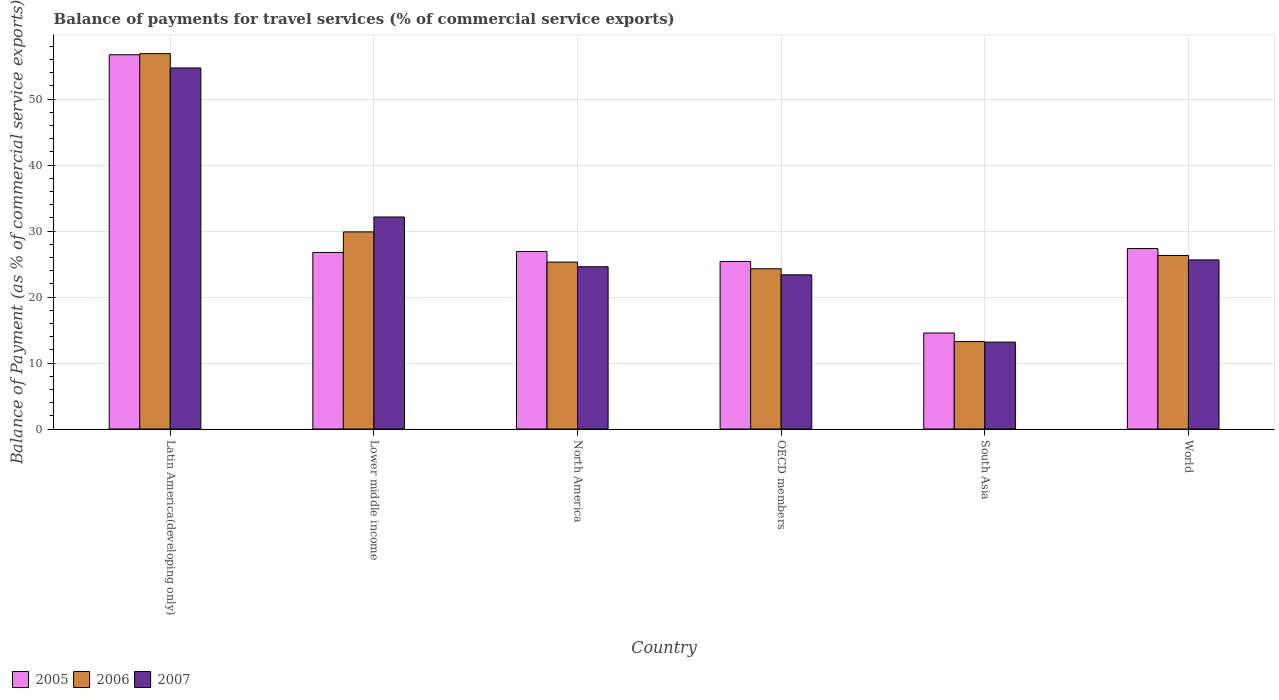How many different coloured bars are there?
Ensure brevity in your answer.  3. In how many cases, is the number of bars for a given country not equal to the number of legend labels?
Your response must be concise. 0. What is the balance of payments for travel services in 2006 in North America?
Offer a terse response. 25.3. Across all countries, what is the maximum balance of payments for travel services in 2005?
Your answer should be compact. 56.72. Across all countries, what is the minimum balance of payments for travel services in 2007?
Ensure brevity in your answer.  13.17. In which country was the balance of payments for travel services in 2006 maximum?
Give a very brief answer. Latin America(developing only). In which country was the balance of payments for travel services in 2007 minimum?
Give a very brief answer. South Asia. What is the total balance of payments for travel services in 2007 in the graph?
Provide a short and direct response. 173.6. What is the difference between the balance of payments for travel services in 2007 in OECD members and that in World?
Give a very brief answer. -2.26. What is the difference between the balance of payments for travel services in 2007 in North America and the balance of payments for travel services in 2006 in South Asia?
Your response must be concise. 11.34. What is the average balance of payments for travel services in 2007 per country?
Keep it short and to the point. 28.93. What is the difference between the balance of payments for travel services of/in 2005 and balance of payments for travel services of/in 2007 in World?
Make the answer very short. 1.72. What is the ratio of the balance of payments for travel services in 2005 in Latin America(developing only) to that in South Asia?
Make the answer very short. 3.9. Is the difference between the balance of payments for travel services in 2005 in Lower middle income and OECD members greater than the difference between the balance of payments for travel services in 2007 in Lower middle income and OECD members?
Ensure brevity in your answer.  No. What is the difference between the highest and the second highest balance of payments for travel services in 2007?
Your answer should be very brief. 6.51. What is the difference between the highest and the lowest balance of payments for travel services in 2005?
Your answer should be compact. 42.17. What does the 1st bar from the left in South Asia represents?
Ensure brevity in your answer.  2005. What does the 1st bar from the right in North America represents?
Provide a succinct answer. 2007. Is it the case that in every country, the sum of the balance of payments for travel services in 2005 and balance of payments for travel services in 2007 is greater than the balance of payments for travel services in 2006?
Give a very brief answer. Yes. How many bars are there?
Make the answer very short. 18. Are all the bars in the graph horizontal?
Make the answer very short. No. What is the difference between two consecutive major ticks on the Y-axis?
Your response must be concise. 10. Does the graph contain any zero values?
Offer a very short reply. No. Does the graph contain grids?
Make the answer very short. Yes. What is the title of the graph?
Your answer should be very brief. Balance of payments for travel services (% of commercial service exports). What is the label or title of the X-axis?
Your answer should be very brief. Country. What is the label or title of the Y-axis?
Keep it short and to the point. Balance of Payment (as % of commercial service exports). What is the Balance of Payment (as % of commercial service exports) of 2005 in Latin America(developing only)?
Your response must be concise. 56.72. What is the Balance of Payment (as % of commercial service exports) of 2006 in Latin America(developing only)?
Ensure brevity in your answer.  56.89. What is the Balance of Payment (as % of commercial service exports) of 2007 in Latin America(developing only)?
Provide a succinct answer. 54.72. What is the Balance of Payment (as % of commercial service exports) in 2005 in Lower middle income?
Your response must be concise. 26.76. What is the Balance of Payment (as % of commercial service exports) of 2006 in Lower middle income?
Make the answer very short. 29.87. What is the Balance of Payment (as % of commercial service exports) of 2007 in Lower middle income?
Your answer should be compact. 32.13. What is the Balance of Payment (as % of commercial service exports) of 2005 in North America?
Give a very brief answer. 26.9. What is the Balance of Payment (as % of commercial service exports) of 2006 in North America?
Offer a very short reply. 25.3. What is the Balance of Payment (as % of commercial service exports) of 2007 in North America?
Provide a succinct answer. 24.59. What is the Balance of Payment (as % of commercial service exports) in 2005 in OECD members?
Your response must be concise. 25.39. What is the Balance of Payment (as % of commercial service exports) of 2006 in OECD members?
Provide a short and direct response. 24.29. What is the Balance of Payment (as % of commercial service exports) of 2007 in OECD members?
Give a very brief answer. 23.36. What is the Balance of Payment (as % of commercial service exports) of 2005 in South Asia?
Offer a very short reply. 14.55. What is the Balance of Payment (as % of commercial service exports) of 2006 in South Asia?
Your answer should be very brief. 13.25. What is the Balance of Payment (as % of commercial service exports) of 2007 in South Asia?
Offer a very short reply. 13.17. What is the Balance of Payment (as % of commercial service exports) in 2005 in World?
Give a very brief answer. 27.35. What is the Balance of Payment (as % of commercial service exports) of 2006 in World?
Offer a terse response. 26.3. What is the Balance of Payment (as % of commercial service exports) in 2007 in World?
Offer a very short reply. 25.63. Across all countries, what is the maximum Balance of Payment (as % of commercial service exports) in 2005?
Provide a succinct answer. 56.72. Across all countries, what is the maximum Balance of Payment (as % of commercial service exports) of 2006?
Make the answer very short. 56.89. Across all countries, what is the maximum Balance of Payment (as % of commercial service exports) of 2007?
Provide a succinct answer. 54.72. Across all countries, what is the minimum Balance of Payment (as % of commercial service exports) of 2005?
Offer a very short reply. 14.55. Across all countries, what is the minimum Balance of Payment (as % of commercial service exports) in 2006?
Your response must be concise. 13.25. Across all countries, what is the minimum Balance of Payment (as % of commercial service exports) in 2007?
Offer a very short reply. 13.17. What is the total Balance of Payment (as % of commercial service exports) in 2005 in the graph?
Offer a very short reply. 177.67. What is the total Balance of Payment (as % of commercial service exports) of 2006 in the graph?
Provide a short and direct response. 175.89. What is the total Balance of Payment (as % of commercial service exports) in 2007 in the graph?
Provide a succinct answer. 173.6. What is the difference between the Balance of Payment (as % of commercial service exports) in 2005 in Latin America(developing only) and that in Lower middle income?
Offer a terse response. 29.96. What is the difference between the Balance of Payment (as % of commercial service exports) of 2006 in Latin America(developing only) and that in Lower middle income?
Make the answer very short. 27.01. What is the difference between the Balance of Payment (as % of commercial service exports) of 2007 in Latin America(developing only) and that in Lower middle income?
Give a very brief answer. 22.59. What is the difference between the Balance of Payment (as % of commercial service exports) of 2005 in Latin America(developing only) and that in North America?
Your answer should be compact. 29.82. What is the difference between the Balance of Payment (as % of commercial service exports) of 2006 in Latin America(developing only) and that in North America?
Make the answer very short. 31.59. What is the difference between the Balance of Payment (as % of commercial service exports) of 2007 in Latin America(developing only) and that in North America?
Make the answer very short. 30.13. What is the difference between the Balance of Payment (as % of commercial service exports) of 2005 in Latin America(developing only) and that in OECD members?
Provide a succinct answer. 31.33. What is the difference between the Balance of Payment (as % of commercial service exports) of 2006 in Latin America(developing only) and that in OECD members?
Give a very brief answer. 32.6. What is the difference between the Balance of Payment (as % of commercial service exports) in 2007 in Latin America(developing only) and that in OECD members?
Ensure brevity in your answer.  31.35. What is the difference between the Balance of Payment (as % of commercial service exports) in 2005 in Latin America(developing only) and that in South Asia?
Your response must be concise. 42.17. What is the difference between the Balance of Payment (as % of commercial service exports) of 2006 in Latin America(developing only) and that in South Asia?
Make the answer very short. 43.63. What is the difference between the Balance of Payment (as % of commercial service exports) in 2007 in Latin America(developing only) and that in South Asia?
Your answer should be compact. 41.55. What is the difference between the Balance of Payment (as % of commercial service exports) in 2005 in Latin America(developing only) and that in World?
Your response must be concise. 29.37. What is the difference between the Balance of Payment (as % of commercial service exports) in 2006 in Latin America(developing only) and that in World?
Your response must be concise. 30.58. What is the difference between the Balance of Payment (as % of commercial service exports) of 2007 in Latin America(developing only) and that in World?
Your response must be concise. 29.09. What is the difference between the Balance of Payment (as % of commercial service exports) in 2005 in Lower middle income and that in North America?
Your answer should be very brief. -0.14. What is the difference between the Balance of Payment (as % of commercial service exports) of 2006 in Lower middle income and that in North America?
Your answer should be very brief. 4.58. What is the difference between the Balance of Payment (as % of commercial service exports) in 2007 in Lower middle income and that in North America?
Keep it short and to the point. 7.54. What is the difference between the Balance of Payment (as % of commercial service exports) in 2005 in Lower middle income and that in OECD members?
Offer a very short reply. 1.37. What is the difference between the Balance of Payment (as % of commercial service exports) of 2006 in Lower middle income and that in OECD members?
Offer a terse response. 5.59. What is the difference between the Balance of Payment (as % of commercial service exports) of 2007 in Lower middle income and that in OECD members?
Give a very brief answer. 8.77. What is the difference between the Balance of Payment (as % of commercial service exports) in 2005 in Lower middle income and that in South Asia?
Provide a short and direct response. 12.2. What is the difference between the Balance of Payment (as % of commercial service exports) in 2006 in Lower middle income and that in South Asia?
Your answer should be compact. 16.62. What is the difference between the Balance of Payment (as % of commercial service exports) in 2007 in Lower middle income and that in South Asia?
Make the answer very short. 18.96. What is the difference between the Balance of Payment (as % of commercial service exports) of 2005 in Lower middle income and that in World?
Provide a succinct answer. -0.59. What is the difference between the Balance of Payment (as % of commercial service exports) in 2006 in Lower middle income and that in World?
Make the answer very short. 3.57. What is the difference between the Balance of Payment (as % of commercial service exports) in 2007 in Lower middle income and that in World?
Offer a terse response. 6.5. What is the difference between the Balance of Payment (as % of commercial service exports) of 2005 in North America and that in OECD members?
Your answer should be very brief. 1.51. What is the difference between the Balance of Payment (as % of commercial service exports) in 2006 in North America and that in OECD members?
Give a very brief answer. 1.01. What is the difference between the Balance of Payment (as % of commercial service exports) of 2007 in North America and that in OECD members?
Ensure brevity in your answer.  1.23. What is the difference between the Balance of Payment (as % of commercial service exports) of 2005 in North America and that in South Asia?
Provide a succinct answer. 12.35. What is the difference between the Balance of Payment (as % of commercial service exports) in 2006 in North America and that in South Asia?
Your response must be concise. 12.04. What is the difference between the Balance of Payment (as % of commercial service exports) in 2007 in North America and that in South Asia?
Your answer should be very brief. 11.42. What is the difference between the Balance of Payment (as % of commercial service exports) in 2005 in North America and that in World?
Ensure brevity in your answer.  -0.45. What is the difference between the Balance of Payment (as % of commercial service exports) of 2006 in North America and that in World?
Provide a short and direct response. -1.01. What is the difference between the Balance of Payment (as % of commercial service exports) in 2007 in North America and that in World?
Your answer should be very brief. -1.04. What is the difference between the Balance of Payment (as % of commercial service exports) of 2005 in OECD members and that in South Asia?
Provide a short and direct response. 10.84. What is the difference between the Balance of Payment (as % of commercial service exports) in 2006 in OECD members and that in South Asia?
Ensure brevity in your answer.  11.04. What is the difference between the Balance of Payment (as % of commercial service exports) of 2007 in OECD members and that in South Asia?
Your answer should be compact. 10.2. What is the difference between the Balance of Payment (as % of commercial service exports) in 2005 in OECD members and that in World?
Provide a succinct answer. -1.96. What is the difference between the Balance of Payment (as % of commercial service exports) in 2006 in OECD members and that in World?
Make the answer very short. -2.01. What is the difference between the Balance of Payment (as % of commercial service exports) of 2007 in OECD members and that in World?
Your answer should be very brief. -2.26. What is the difference between the Balance of Payment (as % of commercial service exports) of 2005 in South Asia and that in World?
Offer a very short reply. -12.8. What is the difference between the Balance of Payment (as % of commercial service exports) in 2006 in South Asia and that in World?
Give a very brief answer. -13.05. What is the difference between the Balance of Payment (as % of commercial service exports) of 2007 in South Asia and that in World?
Give a very brief answer. -12.46. What is the difference between the Balance of Payment (as % of commercial service exports) of 2005 in Latin America(developing only) and the Balance of Payment (as % of commercial service exports) of 2006 in Lower middle income?
Your response must be concise. 26.85. What is the difference between the Balance of Payment (as % of commercial service exports) in 2005 in Latin America(developing only) and the Balance of Payment (as % of commercial service exports) in 2007 in Lower middle income?
Your response must be concise. 24.59. What is the difference between the Balance of Payment (as % of commercial service exports) in 2006 in Latin America(developing only) and the Balance of Payment (as % of commercial service exports) in 2007 in Lower middle income?
Ensure brevity in your answer.  24.75. What is the difference between the Balance of Payment (as % of commercial service exports) of 2005 in Latin America(developing only) and the Balance of Payment (as % of commercial service exports) of 2006 in North America?
Keep it short and to the point. 31.42. What is the difference between the Balance of Payment (as % of commercial service exports) of 2005 in Latin America(developing only) and the Balance of Payment (as % of commercial service exports) of 2007 in North America?
Your answer should be compact. 32.13. What is the difference between the Balance of Payment (as % of commercial service exports) in 2006 in Latin America(developing only) and the Balance of Payment (as % of commercial service exports) in 2007 in North America?
Make the answer very short. 32.29. What is the difference between the Balance of Payment (as % of commercial service exports) of 2005 in Latin America(developing only) and the Balance of Payment (as % of commercial service exports) of 2006 in OECD members?
Your response must be concise. 32.43. What is the difference between the Balance of Payment (as % of commercial service exports) in 2005 in Latin America(developing only) and the Balance of Payment (as % of commercial service exports) in 2007 in OECD members?
Your answer should be compact. 33.35. What is the difference between the Balance of Payment (as % of commercial service exports) in 2006 in Latin America(developing only) and the Balance of Payment (as % of commercial service exports) in 2007 in OECD members?
Ensure brevity in your answer.  33.52. What is the difference between the Balance of Payment (as % of commercial service exports) of 2005 in Latin America(developing only) and the Balance of Payment (as % of commercial service exports) of 2006 in South Asia?
Ensure brevity in your answer.  43.47. What is the difference between the Balance of Payment (as % of commercial service exports) in 2005 in Latin America(developing only) and the Balance of Payment (as % of commercial service exports) in 2007 in South Asia?
Offer a very short reply. 43.55. What is the difference between the Balance of Payment (as % of commercial service exports) of 2006 in Latin America(developing only) and the Balance of Payment (as % of commercial service exports) of 2007 in South Asia?
Offer a very short reply. 43.72. What is the difference between the Balance of Payment (as % of commercial service exports) of 2005 in Latin America(developing only) and the Balance of Payment (as % of commercial service exports) of 2006 in World?
Offer a very short reply. 30.42. What is the difference between the Balance of Payment (as % of commercial service exports) in 2005 in Latin America(developing only) and the Balance of Payment (as % of commercial service exports) in 2007 in World?
Your response must be concise. 31.09. What is the difference between the Balance of Payment (as % of commercial service exports) of 2006 in Latin America(developing only) and the Balance of Payment (as % of commercial service exports) of 2007 in World?
Provide a short and direct response. 31.26. What is the difference between the Balance of Payment (as % of commercial service exports) in 2005 in Lower middle income and the Balance of Payment (as % of commercial service exports) in 2006 in North America?
Offer a very short reply. 1.46. What is the difference between the Balance of Payment (as % of commercial service exports) in 2005 in Lower middle income and the Balance of Payment (as % of commercial service exports) in 2007 in North America?
Your response must be concise. 2.17. What is the difference between the Balance of Payment (as % of commercial service exports) of 2006 in Lower middle income and the Balance of Payment (as % of commercial service exports) of 2007 in North America?
Offer a terse response. 5.28. What is the difference between the Balance of Payment (as % of commercial service exports) of 2005 in Lower middle income and the Balance of Payment (as % of commercial service exports) of 2006 in OECD members?
Provide a short and direct response. 2.47. What is the difference between the Balance of Payment (as % of commercial service exports) in 2005 in Lower middle income and the Balance of Payment (as % of commercial service exports) in 2007 in OECD members?
Your response must be concise. 3.39. What is the difference between the Balance of Payment (as % of commercial service exports) in 2006 in Lower middle income and the Balance of Payment (as % of commercial service exports) in 2007 in OECD members?
Your answer should be compact. 6.51. What is the difference between the Balance of Payment (as % of commercial service exports) in 2005 in Lower middle income and the Balance of Payment (as % of commercial service exports) in 2006 in South Asia?
Your response must be concise. 13.51. What is the difference between the Balance of Payment (as % of commercial service exports) in 2005 in Lower middle income and the Balance of Payment (as % of commercial service exports) in 2007 in South Asia?
Ensure brevity in your answer.  13.59. What is the difference between the Balance of Payment (as % of commercial service exports) in 2006 in Lower middle income and the Balance of Payment (as % of commercial service exports) in 2007 in South Asia?
Your answer should be compact. 16.7. What is the difference between the Balance of Payment (as % of commercial service exports) of 2005 in Lower middle income and the Balance of Payment (as % of commercial service exports) of 2006 in World?
Give a very brief answer. 0.46. What is the difference between the Balance of Payment (as % of commercial service exports) of 2005 in Lower middle income and the Balance of Payment (as % of commercial service exports) of 2007 in World?
Provide a succinct answer. 1.13. What is the difference between the Balance of Payment (as % of commercial service exports) of 2006 in Lower middle income and the Balance of Payment (as % of commercial service exports) of 2007 in World?
Provide a succinct answer. 4.25. What is the difference between the Balance of Payment (as % of commercial service exports) of 2005 in North America and the Balance of Payment (as % of commercial service exports) of 2006 in OECD members?
Provide a succinct answer. 2.61. What is the difference between the Balance of Payment (as % of commercial service exports) in 2005 in North America and the Balance of Payment (as % of commercial service exports) in 2007 in OECD members?
Your response must be concise. 3.53. What is the difference between the Balance of Payment (as % of commercial service exports) in 2006 in North America and the Balance of Payment (as % of commercial service exports) in 2007 in OECD members?
Give a very brief answer. 1.93. What is the difference between the Balance of Payment (as % of commercial service exports) of 2005 in North America and the Balance of Payment (as % of commercial service exports) of 2006 in South Asia?
Offer a terse response. 13.65. What is the difference between the Balance of Payment (as % of commercial service exports) of 2005 in North America and the Balance of Payment (as % of commercial service exports) of 2007 in South Asia?
Offer a terse response. 13.73. What is the difference between the Balance of Payment (as % of commercial service exports) in 2006 in North America and the Balance of Payment (as % of commercial service exports) in 2007 in South Asia?
Ensure brevity in your answer.  12.13. What is the difference between the Balance of Payment (as % of commercial service exports) in 2005 in North America and the Balance of Payment (as % of commercial service exports) in 2006 in World?
Give a very brief answer. 0.6. What is the difference between the Balance of Payment (as % of commercial service exports) of 2005 in North America and the Balance of Payment (as % of commercial service exports) of 2007 in World?
Provide a succinct answer. 1.27. What is the difference between the Balance of Payment (as % of commercial service exports) in 2006 in North America and the Balance of Payment (as % of commercial service exports) in 2007 in World?
Your response must be concise. -0.33. What is the difference between the Balance of Payment (as % of commercial service exports) in 2005 in OECD members and the Balance of Payment (as % of commercial service exports) in 2006 in South Asia?
Your response must be concise. 12.14. What is the difference between the Balance of Payment (as % of commercial service exports) of 2005 in OECD members and the Balance of Payment (as % of commercial service exports) of 2007 in South Asia?
Your answer should be very brief. 12.22. What is the difference between the Balance of Payment (as % of commercial service exports) in 2006 in OECD members and the Balance of Payment (as % of commercial service exports) in 2007 in South Asia?
Offer a terse response. 11.12. What is the difference between the Balance of Payment (as % of commercial service exports) of 2005 in OECD members and the Balance of Payment (as % of commercial service exports) of 2006 in World?
Ensure brevity in your answer.  -0.91. What is the difference between the Balance of Payment (as % of commercial service exports) in 2005 in OECD members and the Balance of Payment (as % of commercial service exports) in 2007 in World?
Your response must be concise. -0.24. What is the difference between the Balance of Payment (as % of commercial service exports) in 2006 in OECD members and the Balance of Payment (as % of commercial service exports) in 2007 in World?
Provide a succinct answer. -1.34. What is the difference between the Balance of Payment (as % of commercial service exports) in 2005 in South Asia and the Balance of Payment (as % of commercial service exports) in 2006 in World?
Provide a short and direct response. -11.75. What is the difference between the Balance of Payment (as % of commercial service exports) of 2005 in South Asia and the Balance of Payment (as % of commercial service exports) of 2007 in World?
Provide a succinct answer. -11.07. What is the difference between the Balance of Payment (as % of commercial service exports) in 2006 in South Asia and the Balance of Payment (as % of commercial service exports) in 2007 in World?
Offer a very short reply. -12.38. What is the average Balance of Payment (as % of commercial service exports) of 2005 per country?
Offer a very short reply. 29.61. What is the average Balance of Payment (as % of commercial service exports) of 2006 per country?
Offer a very short reply. 29.32. What is the average Balance of Payment (as % of commercial service exports) of 2007 per country?
Your answer should be compact. 28.93. What is the difference between the Balance of Payment (as % of commercial service exports) in 2005 and Balance of Payment (as % of commercial service exports) in 2006 in Latin America(developing only)?
Your answer should be compact. -0.17. What is the difference between the Balance of Payment (as % of commercial service exports) of 2005 and Balance of Payment (as % of commercial service exports) of 2007 in Latin America(developing only)?
Offer a very short reply. 2. What is the difference between the Balance of Payment (as % of commercial service exports) in 2006 and Balance of Payment (as % of commercial service exports) in 2007 in Latin America(developing only)?
Keep it short and to the point. 2.17. What is the difference between the Balance of Payment (as % of commercial service exports) of 2005 and Balance of Payment (as % of commercial service exports) of 2006 in Lower middle income?
Your response must be concise. -3.12. What is the difference between the Balance of Payment (as % of commercial service exports) in 2005 and Balance of Payment (as % of commercial service exports) in 2007 in Lower middle income?
Offer a very short reply. -5.37. What is the difference between the Balance of Payment (as % of commercial service exports) of 2006 and Balance of Payment (as % of commercial service exports) of 2007 in Lower middle income?
Offer a very short reply. -2.26. What is the difference between the Balance of Payment (as % of commercial service exports) of 2005 and Balance of Payment (as % of commercial service exports) of 2006 in North America?
Give a very brief answer. 1.6. What is the difference between the Balance of Payment (as % of commercial service exports) of 2005 and Balance of Payment (as % of commercial service exports) of 2007 in North America?
Provide a succinct answer. 2.31. What is the difference between the Balance of Payment (as % of commercial service exports) in 2006 and Balance of Payment (as % of commercial service exports) in 2007 in North America?
Give a very brief answer. 0.7. What is the difference between the Balance of Payment (as % of commercial service exports) of 2005 and Balance of Payment (as % of commercial service exports) of 2006 in OECD members?
Make the answer very short. 1.1. What is the difference between the Balance of Payment (as % of commercial service exports) of 2005 and Balance of Payment (as % of commercial service exports) of 2007 in OECD members?
Provide a short and direct response. 2.03. What is the difference between the Balance of Payment (as % of commercial service exports) of 2006 and Balance of Payment (as % of commercial service exports) of 2007 in OECD members?
Make the answer very short. 0.92. What is the difference between the Balance of Payment (as % of commercial service exports) of 2005 and Balance of Payment (as % of commercial service exports) of 2006 in South Asia?
Your response must be concise. 1.3. What is the difference between the Balance of Payment (as % of commercial service exports) of 2005 and Balance of Payment (as % of commercial service exports) of 2007 in South Asia?
Give a very brief answer. 1.38. What is the difference between the Balance of Payment (as % of commercial service exports) in 2006 and Balance of Payment (as % of commercial service exports) in 2007 in South Asia?
Keep it short and to the point. 0.08. What is the difference between the Balance of Payment (as % of commercial service exports) of 2005 and Balance of Payment (as % of commercial service exports) of 2006 in World?
Provide a short and direct response. 1.05. What is the difference between the Balance of Payment (as % of commercial service exports) in 2005 and Balance of Payment (as % of commercial service exports) in 2007 in World?
Provide a short and direct response. 1.72. What is the difference between the Balance of Payment (as % of commercial service exports) in 2006 and Balance of Payment (as % of commercial service exports) in 2007 in World?
Your answer should be compact. 0.68. What is the ratio of the Balance of Payment (as % of commercial service exports) in 2005 in Latin America(developing only) to that in Lower middle income?
Give a very brief answer. 2.12. What is the ratio of the Balance of Payment (as % of commercial service exports) in 2006 in Latin America(developing only) to that in Lower middle income?
Your response must be concise. 1.9. What is the ratio of the Balance of Payment (as % of commercial service exports) in 2007 in Latin America(developing only) to that in Lower middle income?
Offer a very short reply. 1.7. What is the ratio of the Balance of Payment (as % of commercial service exports) of 2005 in Latin America(developing only) to that in North America?
Provide a short and direct response. 2.11. What is the ratio of the Balance of Payment (as % of commercial service exports) in 2006 in Latin America(developing only) to that in North America?
Offer a very short reply. 2.25. What is the ratio of the Balance of Payment (as % of commercial service exports) in 2007 in Latin America(developing only) to that in North America?
Keep it short and to the point. 2.23. What is the ratio of the Balance of Payment (as % of commercial service exports) in 2005 in Latin America(developing only) to that in OECD members?
Give a very brief answer. 2.23. What is the ratio of the Balance of Payment (as % of commercial service exports) in 2006 in Latin America(developing only) to that in OECD members?
Keep it short and to the point. 2.34. What is the ratio of the Balance of Payment (as % of commercial service exports) in 2007 in Latin America(developing only) to that in OECD members?
Your answer should be compact. 2.34. What is the ratio of the Balance of Payment (as % of commercial service exports) of 2005 in Latin America(developing only) to that in South Asia?
Offer a very short reply. 3.9. What is the ratio of the Balance of Payment (as % of commercial service exports) in 2006 in Latin America(developing only) to that in South Asia?
Provide a succinct answer. 4.29. What is the ratio of the Balance of Payment (as % of commercial service exports) in 2007 in Latin America(developing only) to that in South Asia?
Make the answer very short. 4.15. What is the ratio of the Balance of Payment (as % of commercial service exports) of 2005 in Latin America(developing only) to that in World?
Ensure brevity in your answer.  2.07. What is the ratio of the Balance of Payment (as % of commercial service exports) in 2006 in Latin America(developing only) to that in World?
Offer a very short reply. 2.16. What is the ratio of the Balance of Payment (as % of commercial service exports) of 2007 in Latin America(developing only) to that in World?
Make the answer very short. 2.14. What is the ratio of the Balance of Payment (as % of commercial service exports) of 2005 in Lower middle income to that in North America?
Your answer should be very brief. 0.99. What is the ratio of the Balance of Payment (as % of commercial service exports) of 2006 in Lower middle income to that in North America?
Offer a very short reply. 1.18. What is the ratio of the Balance of Payment (as % of commercial service exports) of 2007 in Lower middle income to that in North America?
Make the answer very short. 1.31. What is the ratio of the Balance of Payment (as % of commercial service exports) of 2005 in Lower middle income to that in OECD members?
Provide a short and direct response. 1.05. What is the ratio of the Balance of Payment (as % of commercial service exports) of 2006 in Lower middle income to that in OECD members?
Provide a succinct answer. 1.23. What is the ratio of the Balance of Payment (as % of commercial service exports) in 2007 in Lower middle income to that in OECD members?
Provide a short and direct response. 1.38. What is the ratio of the Balance of Payment (as % of commercial service exports) in 2005 in Lower middle income to that in South Asia?
Ensure brevity in your answer.  1.84. What is the ratio of the Balance of Payment (as % of commercial service exports) of 2006 in Lower middle income to that in South Asia?
Give a very brief answer. 2.25. What is the ratio of the Balance of Payment (as % of commercial service exports) in 2007 in Lower middle income to that in South Asia?
Provide a short and direct response. 2.44. What is the ratio of the Balance of Payment (as % of commercial service exports) of 2005 in Lower middle income to that in World?
Keep it short and to the point. 0.98. What is the ratio of the Balance of Payment (as % of commercial service exports) of 2006 in Lower middle income to that in World?
Your response must be concise. 1.14. What is the ratio of the Balance of Payment (as % of commercial service exports) of 2007 in Lower middle income to that in World?
Offer a terse response. 1.25. What is the ratio of the Balance of Payment (as % of commercial service exports) in 2005 in North America to that in OECD members?
Provide a succinct answer. 1.06. What is the ratio of the Balance of Payment (as % of commercial service exports) in 2006 in North America to that in OECD members?
Keep it short and to the point. 1.04. What is the ratio of the Balance of Payment (as % of commercial service exports) of 2007 in North America to that in OECD members?
Keep it short and to the point. 1.05. What is the ratio of the Balance of Payment (as % of commercial service exports) in 2005 in North America to that in South Asia?
Your response must be concise. 1.85. What is the ratio of the Balance of Payment (as % of commercial service exports) in 2006 in North America to that in South Asia?
Your response must be concise. 1.91. What is the ratio of the Balance of Payment (as % of commercial service exports) in 2007 in North America to that in South Asia?
Give a very brief answer. 1.87. What is the ratio of the Balance of Payment (as % of commercial service exports) of 2005 in North America to that in World?
Provide a short and direct response. 0.98. What is the ratio of the Balance of Payment (as % of commercial service exports) in 2006 in North America to that in World?
Keep it short and to the point. 0.96. What is the ratio of the Balance of Payment (as % of commercial service exports) of 2007 in North America to that in World?
Offer a very short reply. 0.96. What is the ratio of the Balance of Payment (as % of commercial service exports) in 2005 in OECD members to that in South Asia?
Your answer should be compact. 1.74. What is the ratio of the Balance of Payment (as % of commercial service exports) of 2006 in OECD members to that in South Asia?
Make the answer very short. 1.83. What is the ratio of the Balance of Payment (as % of commercial service exports) of 2007 in OECD members to that in South Asia?
Your answer should be compact. 1.77. What is the ratio of the Balance of Payment (as % of commercial service exports) in 2005 in OECD members to that in World?
Provide a short and direct response. 0.93. What is the ratio of the Balance of Payment (as % of commercial service exports) in 2006 in OECD members to that in World?
Ensure brevity in your answer.  0.92. What is the ratio of the Balance of Payment (as % of commercial service exports) in 2007 in OECD members to that in World?
Offer a very short reply. 0.91. What is the ratio of the Balance of Payment (as % of commercial service exports) in 2005 in South Asia to that in World?
Make the answer very short. 0.53. What is the ratio of the Balance of Payment (as % of commercial service exports) of 2006 in South Asia to that in World?
Keep it short and to the point. 0.5. What is the ratio of the Balance of Payment (as % of commercial service exports) in 2007 in South Asia to that in World?
Your answer should be compact. 0.51. What is the difference between the highest and the second highest Balance of Payment (as % of commercial service exports) in 2005?
Provide a short and direct response. 29.37. What is the difference between the highest and the second highest Balance of Payment (as % of commercial service exports) in 2006?
Your answer should be very brief. 27.01. What is the difference between the highest and the second highest Balance of Payment (as % of commercial service exports) in 2007?
Ensure brevity in your answer.  22.59. What is the difference between the highest and the lowest Balance of Payment (as % of commercial service exports) of 2005?
Provide a succinct answer. 42.17. What is the difference between the highest and the lowest Balance of Payment (as % of commercial service exports) in 2006?
Your response must be concise. 43.63. What is the difference between the highest and the lowest Balance of Payment (as % of commercial service exports) in 2007?
Your answer should be compact. 41.55. 